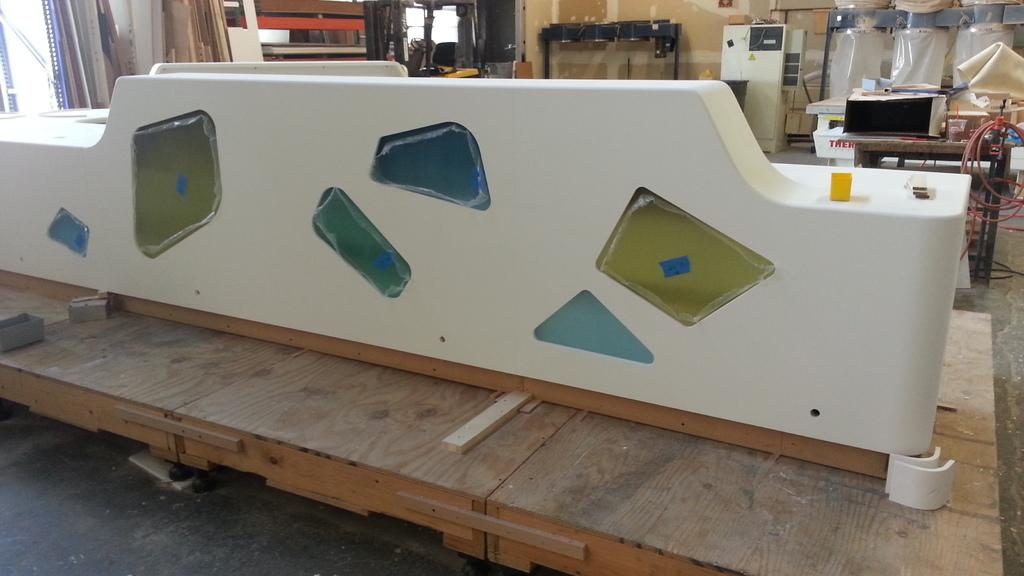What type of furniture is present in the image? There is a table in the image. What colors are used for the table? The table is brown and white in color. What can be seen in the background of the image? There are machines visible in the background. What is the color of the wall in the image? The wall is cream in color. Where is the window located in the image? The window is on the left side of the image. Can you see any boats in the image? There are no boats present in the image. Is there a rock formation visible through the window? There is no rock formation visible through the window; the window shows a view of the surroundings, but no specific geological features are mentioned in the facts. 